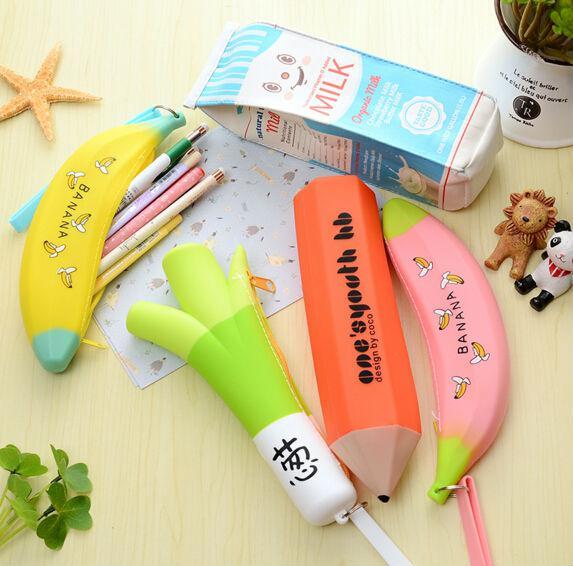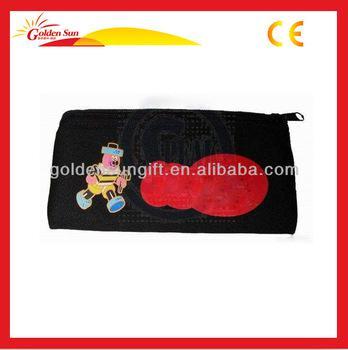The first image is the image on the left, the second image is the image on the right. Considering the images on both sides, is "At least one of the pouches contains an Eiffel tower object." valid? Answer yes or no. No. The first image is the image on the left, the second image is the image on the right. Analyze the images presented: Is the assertion "At least one image shows an open zipper case with rounded corners and a polka-dotted black interior filled with supplies." valid? Answer yes or no. No. 